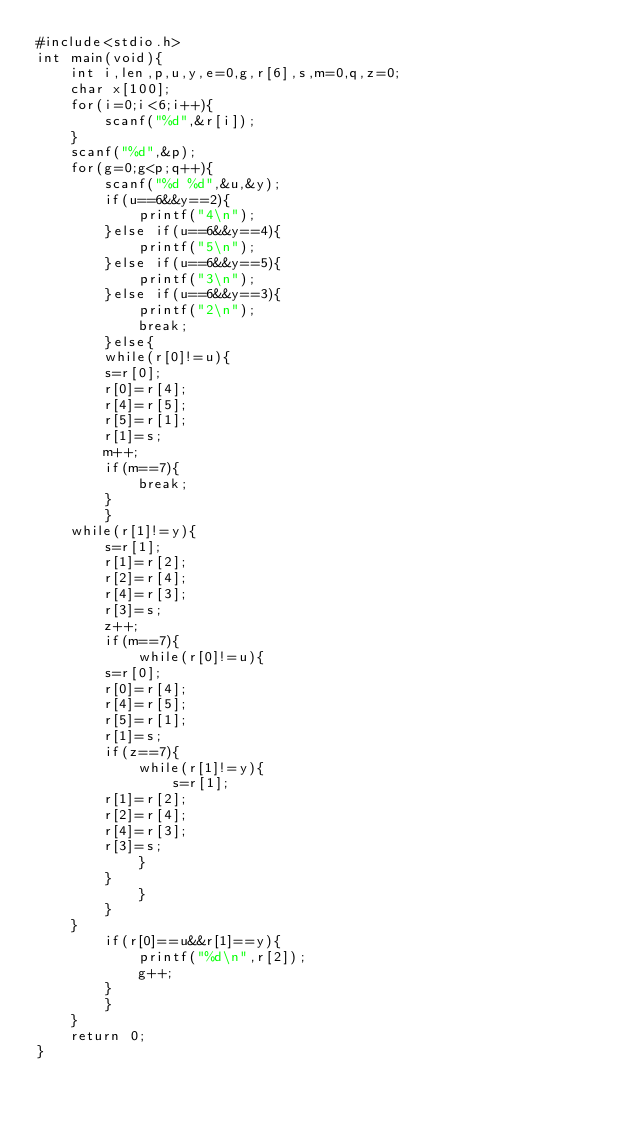Convert code to text. <code><loc_0><loc_0><loc_500><loc_500><_C_>#include<stdio.h>
int main(void){
    int i,len,p,u,y,e=0,g,r[6],s,m=0,q,z=0;
    char x[100];
    for(i=0;i<6;i++){
    	scanf("%d",&r[i]);
    }
    scanf("%d",&p);
    for(g=0;g<p;q++){
    	scanf("%d %d",&u,&y);
    	if(u==6&&y==2){
    		printf("4\n");
    	}else if(u==6&&y==4){
    		printf("5\n");
    	}else if(u==6&&y==5){
    		printf("3\n");
    	}else if(u==6&&y==3){
    		printf("2\n");
    		break;
    	}else{
    	while(r[0]!=u){
    	s=r[0];
    	r[0]=r[4];
    	r[4]=r[5];
    	r[5]=r[1];
    	r[1]=s;
    	m++;
    	if(m==7){
    		break;
    	}
    	}
    while(r[1]!=y){
    	s=r[1];
    	r[1]=r[2];
    	r[2]=r[4];
    	r[4]=r[3];
    	r[3]=s;
    	z++;
    	if(m==7){
    		while(r[0]!=u){
    	s=r[0];
    	r[0]=r[4];
    	r[4]=r[5];
    	r[5]=r[1];
    	r[1]=s;
    	if(z==7){
    		while(r[1]!=y){
    			s=r[1];
    	r[1]=r[2];
    	r[2]=r[4];
    	r[4]=r[3];
    	r[3]=s;
    		}
    	}
    		}
    	}
    }
    	if(r[0]==u&&r[1]==y){
    		printf("%d\n",r[2]);
    		g++;
    	}
    	}
    }
    return 0;
}</code> 